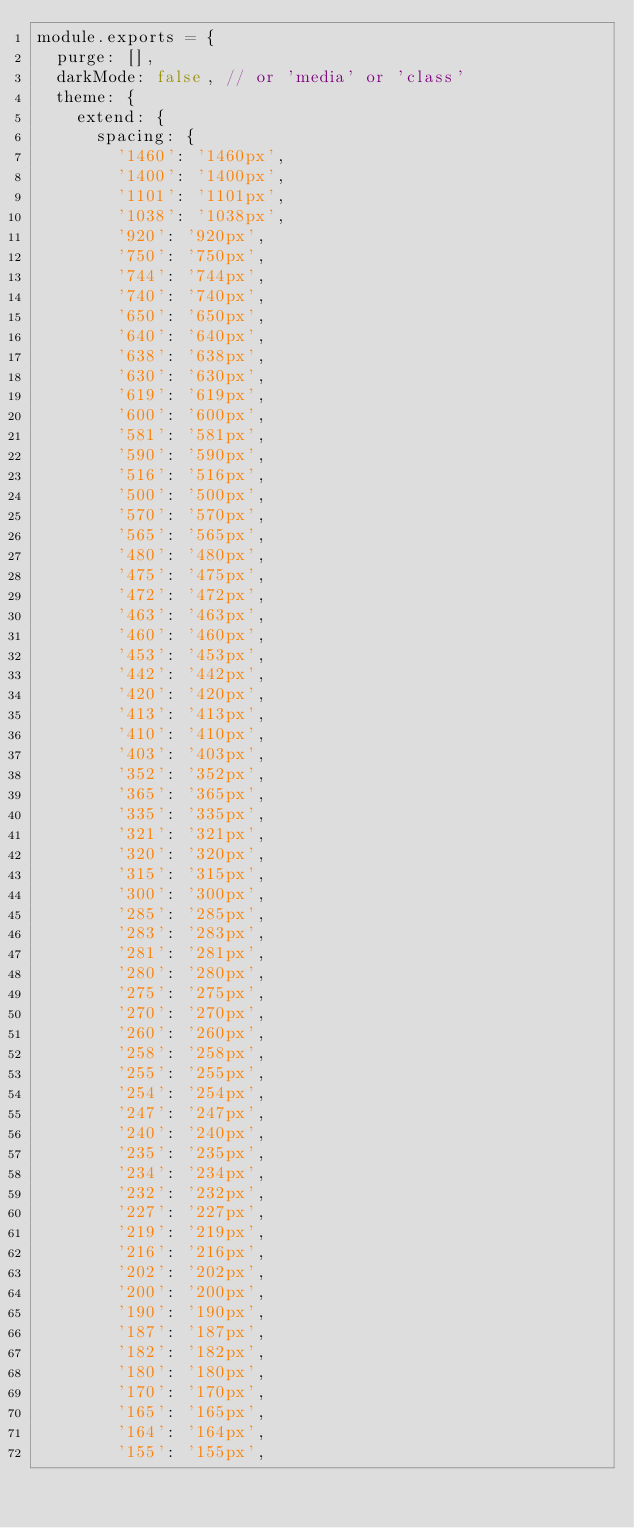<code> <loc_0><loc_0><loc_500><loc_500><_JavaScript_>module.exports = {
  purge: [],
  darkMode: false, // or 'media' or 'class'
  theme: {
    extend: {
      spacing: {
        '1460': '1460px',
        '1400': '1400px',
        '1101': '1101px',
        '1038': '1038px',
        '920': '920px',
        '750': '750px',
        '744': '744px',
        '740': '740px',
        '650': '650px',
        '640': '640px',
        '638': '638px',
        '630': '630px',
        '619': '619px',
        '600': '600px',
        '581': '581px',
        '590': '590px',
        '516': '516px',
        '500': '500px',
        '570': '570px',
        '565': '565px',
        '480': '480px',
        '475': '475px',
        '472': '472px',
        '463': '463px',
        '460': '460px',
        '453': '453px',
        '442': '442px',
        '420': '420px',
        '413': '413px',
        '410': '410px',
        '403': '403px',
        '352': '352px',
        '365': '365px',
        '335': '335px',
        '321': '321px',
        '320': '320px',
        '315': '315px',
        '300': '300px',
        '285': '285px',
        '283': '283px',
        '281': '281px',
        '280': '280px',
        '275': '275px',
        '270': '270px',
        '260': '260px',
        '258': '258px',
        '255': '255px',
        '254': '254px',
        '247': '247px',
        '240': '240px',
        '235': '235px',
        '234': '234px',
        '232': '232px',
        '227': '227px',
        '219': '219px',
        '216': '216px',
        '202': '202px',
        '200': '200px',
        '190': '190px',
        '187': '187px',
        '182': '182px',
        '180': '180px',
        '170': '170px',
        '165': '165px',
        '164': '164px',
        '155': '155px',</code> 